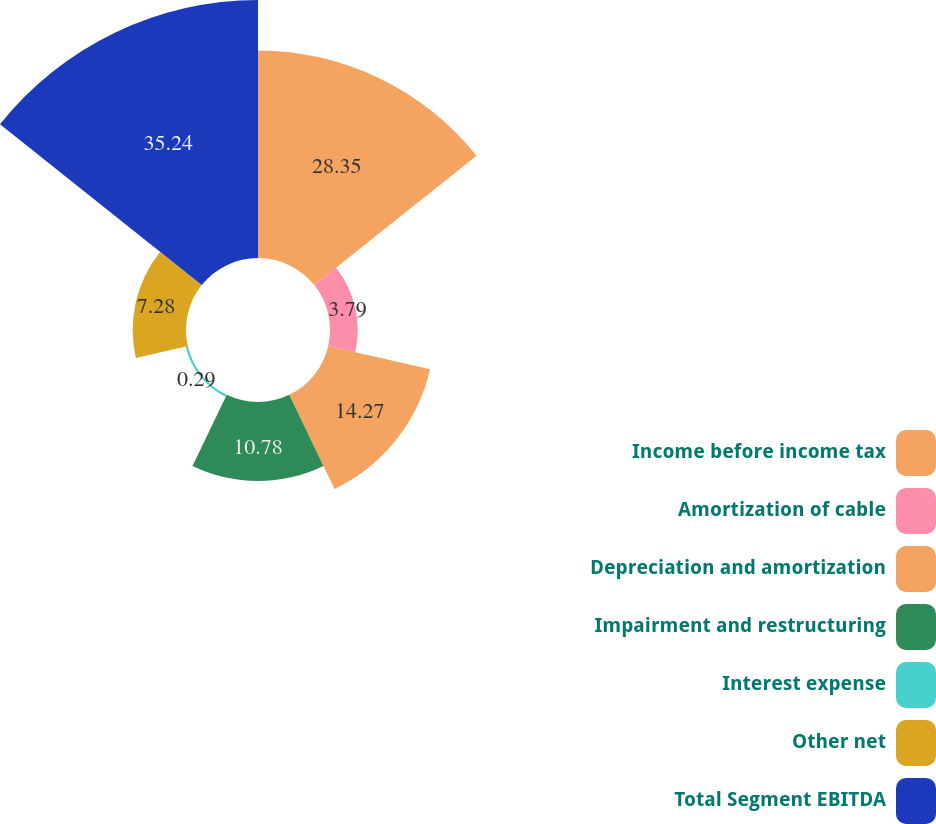Convert chart to OTSL. <chart><loc_0><loc_0><loc_500><loc_500><pie_chart><fcel>Income before income tax<fcel>Amortization of cable<fcel>Depreciation and amortization<fcel>Impairment and restructuring<fcel>Interest expense<fcel>Other net<fcel>Total Segment EBITDA<nl><fcel>28.35%<fcel>3.79%<fcel>14.27%<fcel>10.78%<fcel>0.29%<fcel>7.28%<fcel>35.24%<nl></chart> 